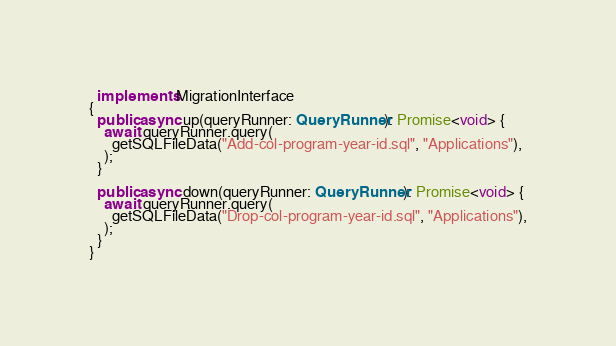<code> <loc_0><loc_0><loc_500><loc_500><_TypeScript_>  implements MigrationInterface
{
  public async up(queryRunner: QueryRunner): Promise<void> {
    await queryRunner.query(
      getSQLFileData("Add-col-program-year-id.sql", "Applications"),
    );
  }

  public async down(queryRunner: QueryRunner): Promise<void> {
    await queryRunner.query(
      getSQLFileData("Drop-col-program-year-id.sql", "Applications"),
    );
  }
}
</code> 